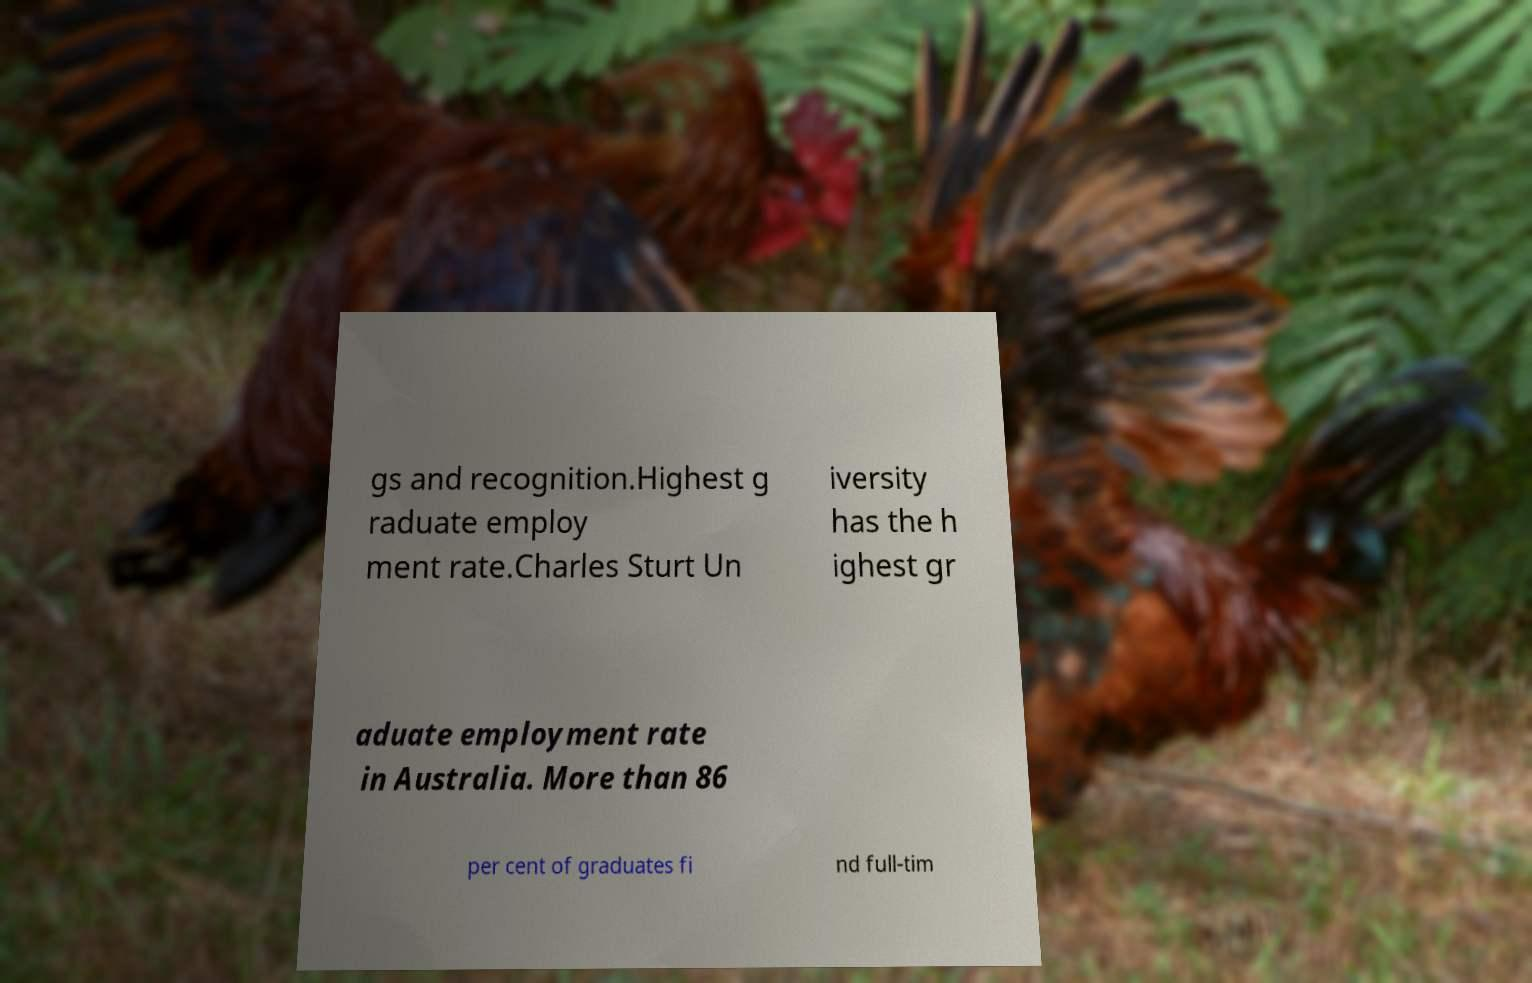I need the written content from this picture converted into text. Can you do that? gs and recognition.Highest g raduate employ ment rate.Charles Sturt Un iversity has the h ighest gr aduate employment rate in Australia. More than 86 per cent of graduates fi nd full-tim 